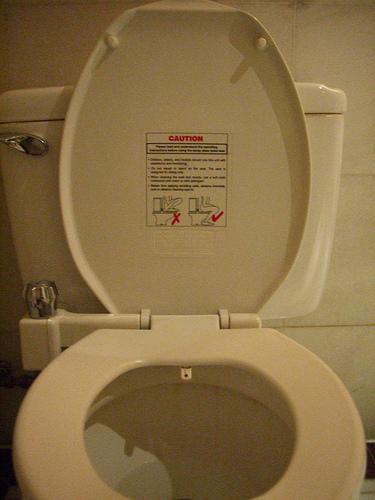How many seats are available on this toilet?
Give a very brief answer. 1. 